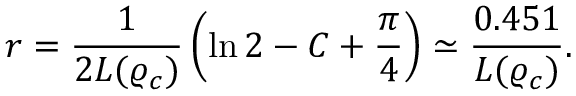Convert formula to latex. <formula><loc_0><loc_0><loc_500><loc_500>r = \frac { 1 } { 2 L ( \varrho _ { c } ) } \left ( \ln 2 - C + \frac { \pi } { 4 } \right ) \simeq \frac { 0 . 4 5 1 } { L ( \varrho _ { c } ) } .</formula> 